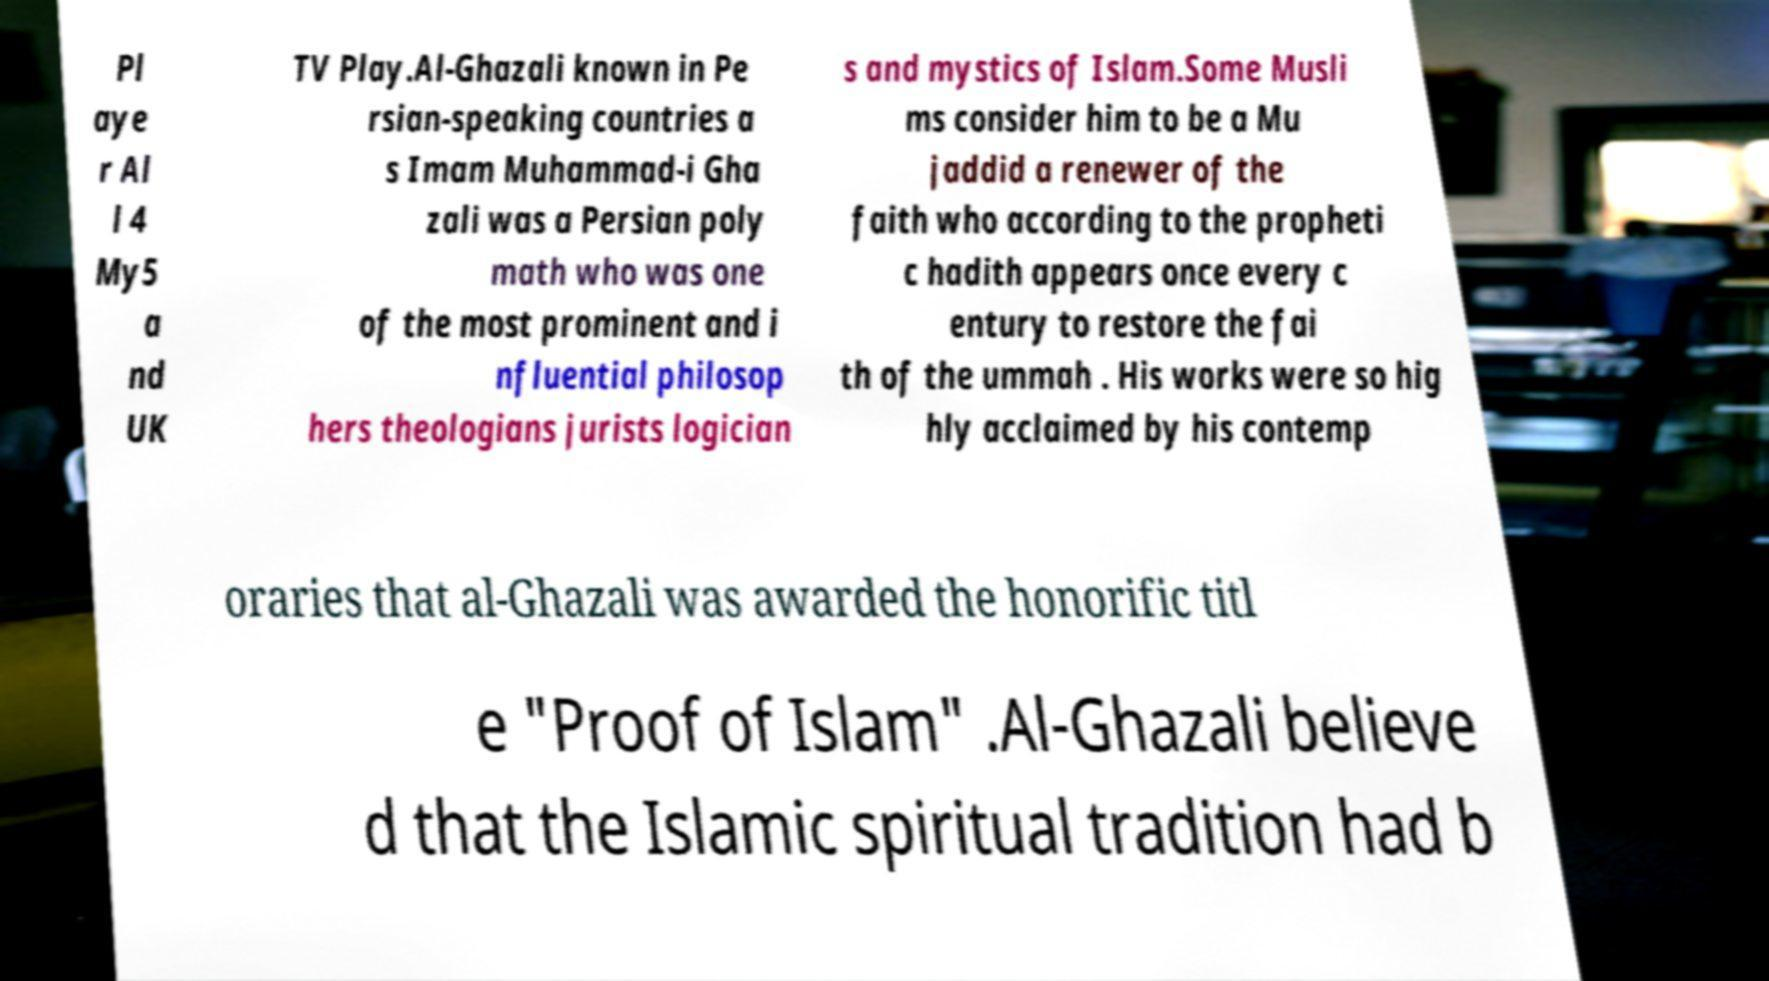I need the written content from this picture converted into text. Can you do that? Pl aye r Al l 4 My5 a nd UK TV Play.Al-Ghazali known in Pe rsian-speaking countries a s Imam Muhammad-i Gha zali was a Persian poly math who was one of the most prominent and i nfluential philosop hers theologians jurists logician s and mystics of Islam.Some Musli ms consider him to be a Mu jaddid a renewer of the faith who according to the propheti c hadith appears once every c entury to restore the fai th of the ummah . His works were so hig hly acclaimed by his contemp oraries that al-Ghazali was awarded the honorific titl e "Proof of Islam" .Al-Ghazali believe d that the Islamic spiritual tradition had b 